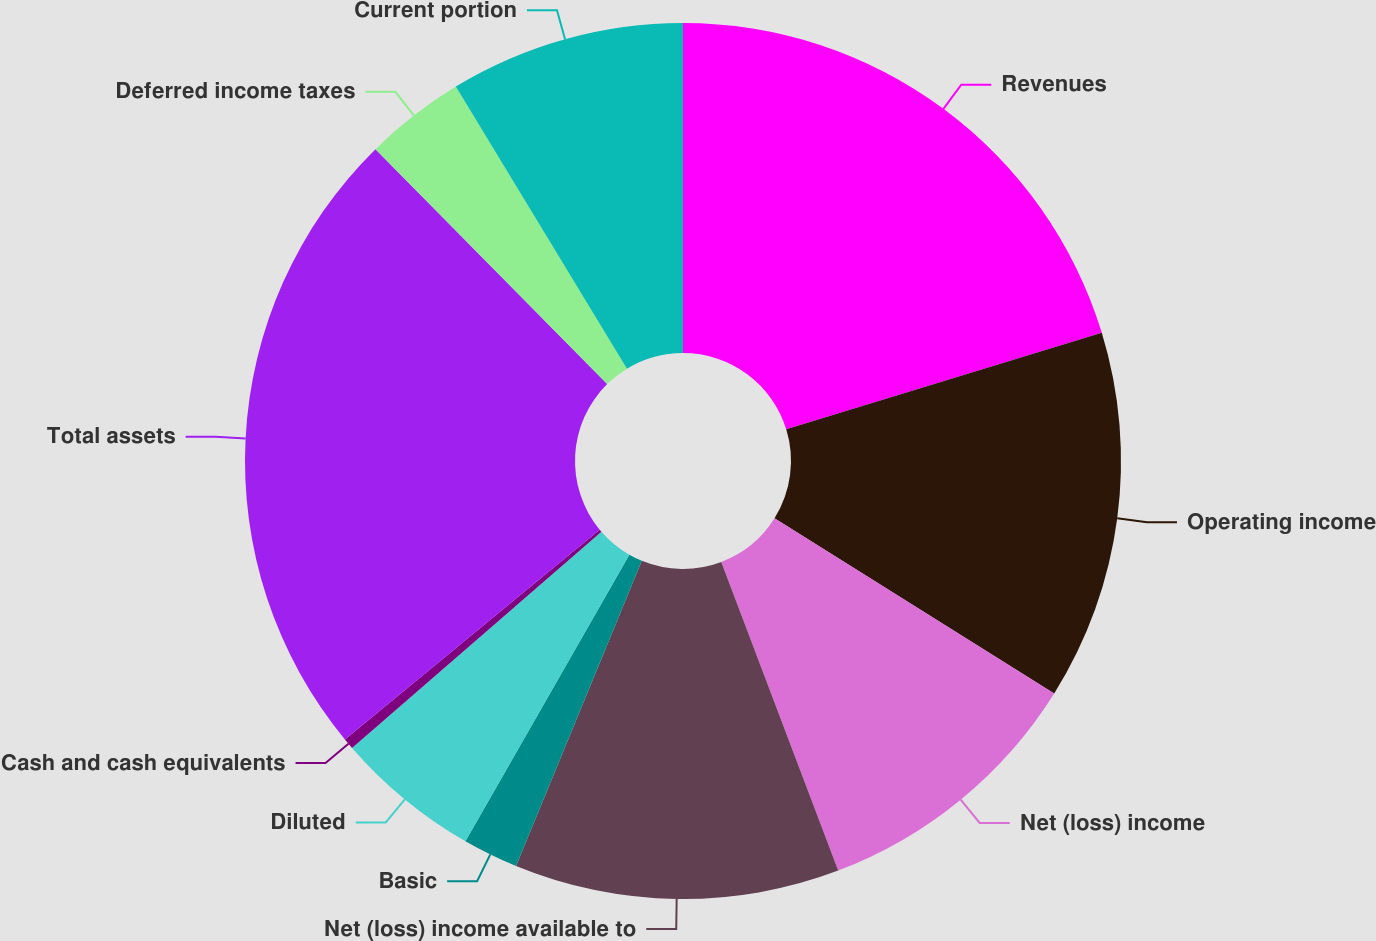<chart> <loc_0><loc_0><loc_500><loc_500><pie_chart><fcel>Revenues<fcel>Operating income<fcel>Net (loss) income<fcel>Net (loss) income available to<fcel>Basic<fcel>Diluted<fcel>Cash and cash equivalents<fcel>Total assets<fcel>Deferred income taxes<fcel>Current portion<nl><fcel>20.27%<fcel>13.64%<fcel>10.33%<fcel>11.99%<fcel>2.05%<fcel>5.36%<fcel>0.4%<fcel>23.58%<fcel>3.71%<fcel>8.68%<nl></chart> 